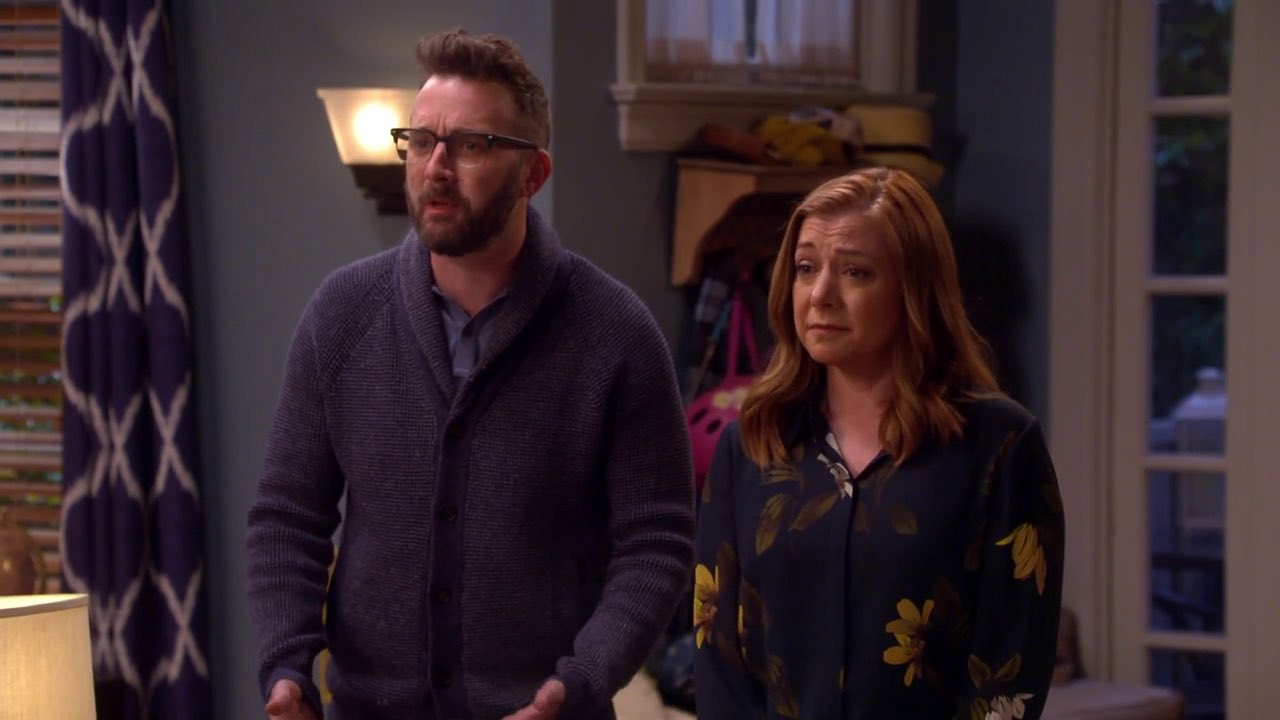Describe the setting in detail. The setting of the image appears to be a cozy living room. On the left, there are curtains with a geometric pattern, partially revealing a window that lets in natural light. There's a wall lamp providing additional warmth to the room. Behind the man, various items such as bags and coats are seen on a piece of furniture, highlighting a lived-in ambiance. The teal walls add a calming touch to the space. Both individuals are dressed casually yet neatly, aligning well with the relaxed, homey environment. 